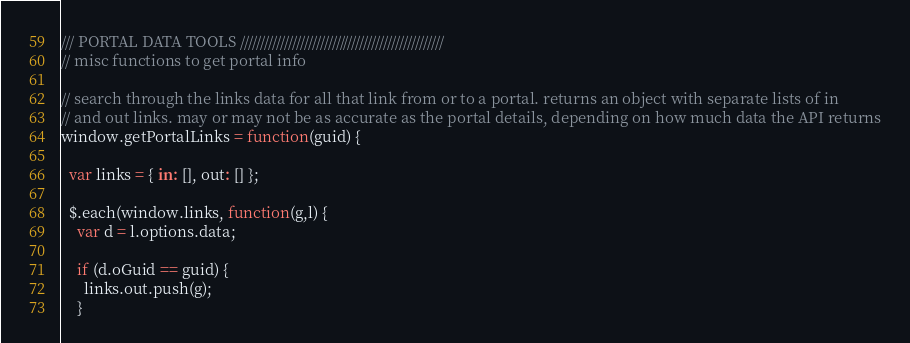<code> <loc_0><loc_0><loc_500><loc_500><_JavaScript_>/// PORTAL DATA TOOLS ///////////////////////////////////////////////////
// misc functions to get portal info

// search through the links data for all that link from or to a portal. returns an object with separate lists of in
// and out links. may or may not be as accurate as the portal details, depending on how much data the API returns
window.getPortalLinks = function(guid) {

  var links = { in: [], out: [] };

  $.each(window.links, function(g,l) {
    var d = l.options.data;

    if (d.oGuid == guid) {
      links.out.push(g);
    }</code> 